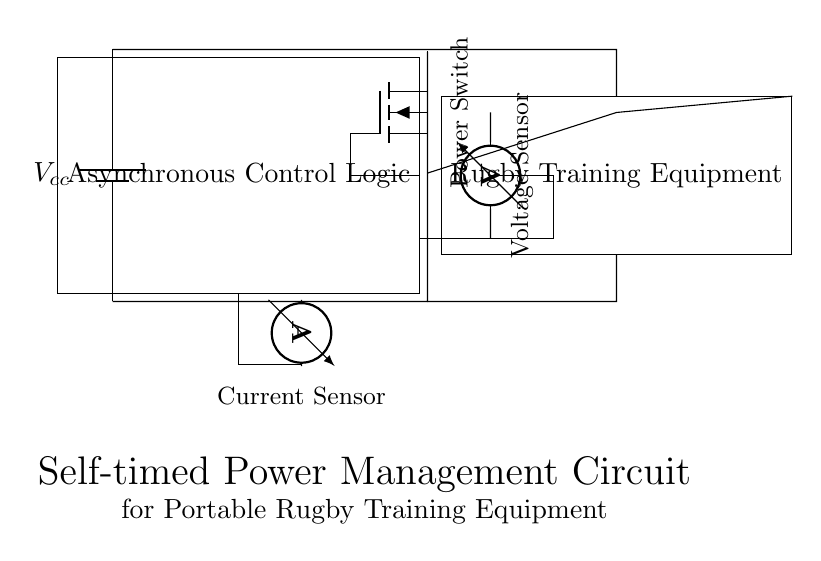What is the main function of the asynchronous control logic? The asynchronous control logic is responsible for managing the operation of the circuit, specifically the power switch based on sensor inputs.
Answer: Managing power switch What component represents the load in the circuit? The load is represented by the rectangle labeled "Rugby Training Equipment," indicating the device that consumes power.
Answer: Rugby Training Equipment How many sensors are present in the circuit? There are two sensors in the circuit, specifically a voltage sensor and a current sensor.
Answer: Two What type of power switch is used in the circuit? The power switch is represented by a nigfete, which indicates a specific type of field-effect transistor used for switching.
Answer: Nigfete What is the purpose of the voltage sensor? The voltage sensor is used to measure the voltage across the rugby training equipment, providing feedback to the control logic for power management.
Answer: Measure voltage How does the current sensor connect to the control logic? The current sensor connects to the control logic via a path that enables the control logic to monitor the current flowing through the circuit. This feedback allows the circuit to make decisions based on current levels.
Answer: Through direct connection 